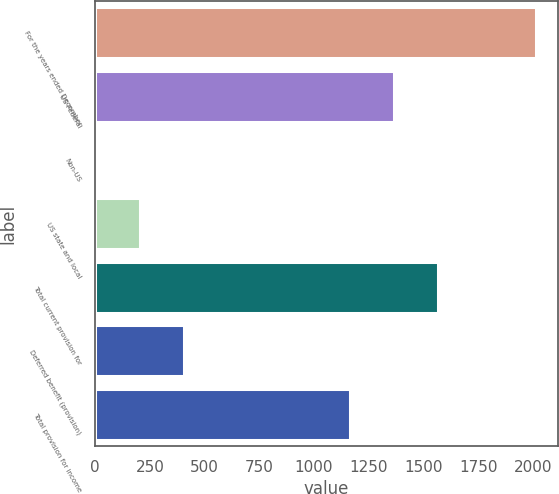<chart> <loc_0><loc_0><loc_500><loc_500><bar_chart><fcel>For the years ended December<fcel>US Federal<fcel>Non-US<fcel>US state and local<fcel>Total current provision for<fcel>Deferred benefit (provision)<fcel>Total provision for income<nl><fcel>2013<fcel>1363.8<fcel>5<fcel>205.8<fcel>1564.6<fcel>406.6<fcel>1163<nl></chart> 